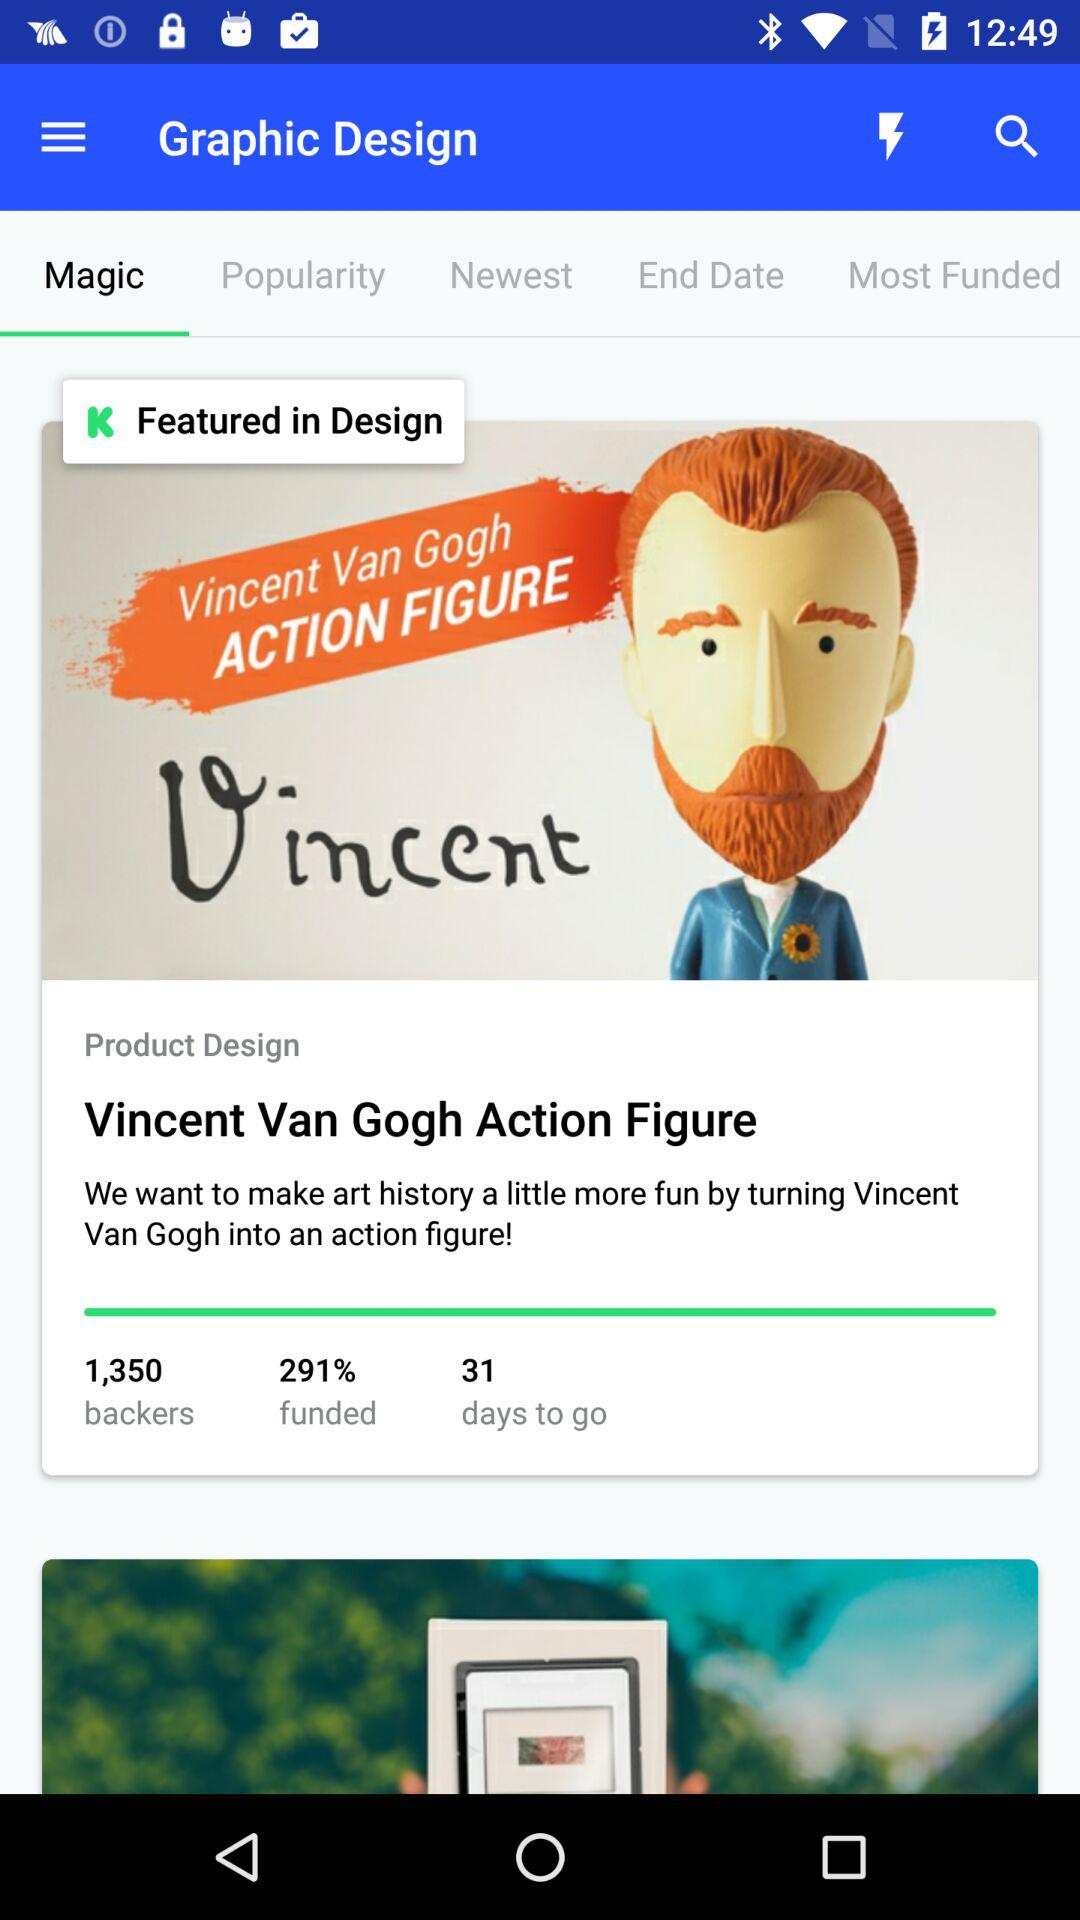What is the number of days to go? The number of days to go is 31. 